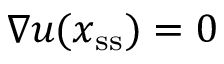Convert formula to latex. <formula><loc_0><loc_0><loc_500><loc_500>\nabla \boldsymbol u ( x _ { s s } ) = 0</formula> 